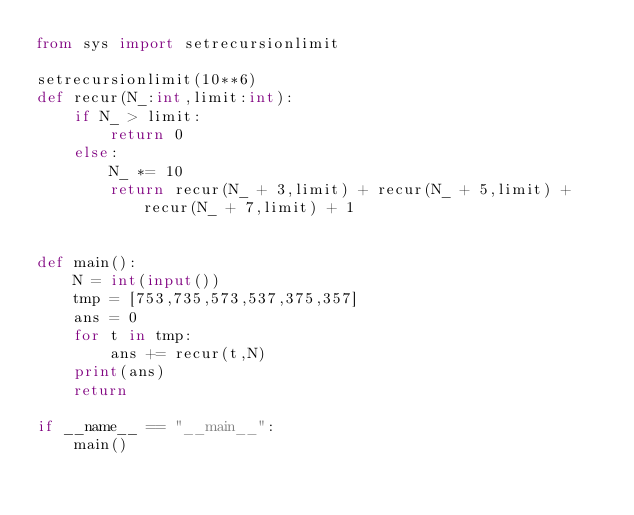Convert code to text. <code><loc_0><loc_0><loc_500><loc_500><_Python_>from sys import setrecursionlimit

setrecursionlimit(10**6)
def recur(N_:int,limit:int):
    if N_ > limit:
        return 0
    else:
        N_ *= 10
        return recur(N_ + 3,limit) + recur(N_ + 5,limit) + recur(N_ + 7,limit) + 1


def main():
    N = int(input())
    tmp = [753,735,573,537,375,357]
    ans = 0
    for t in tmp:
        ans += recur(t,N)
    print(ans)
    return   

if __name__ == "__main__":
    main()</code> 